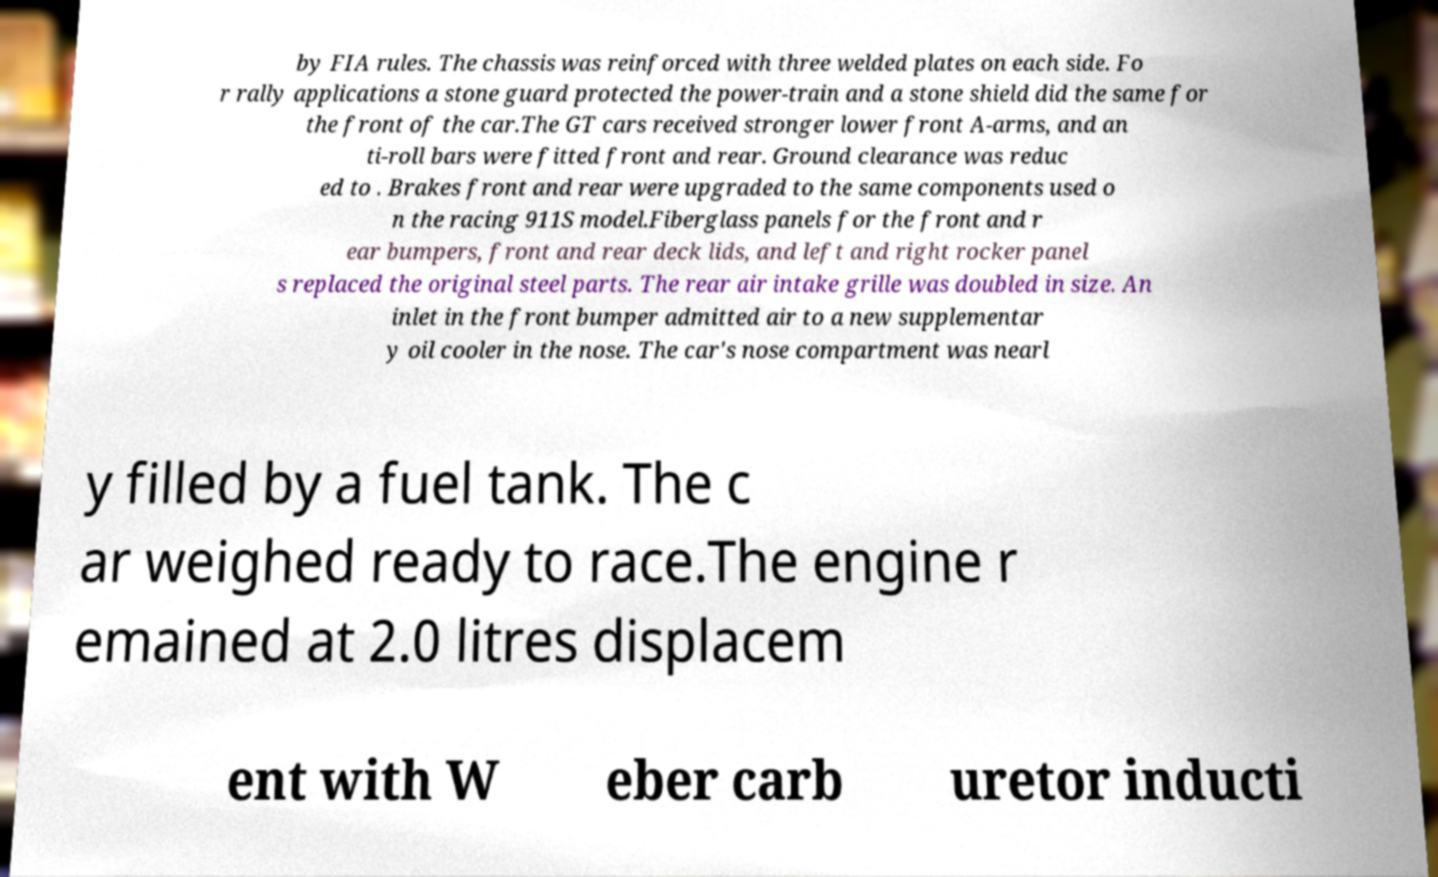Could you extract and type out the text from this image? by FIA rules. The chassis was reinforced with three welded plates on each side. Fo r rally applications a stone guard protected the power-train and a stone shield did the same for the front of the car.The GT cars received stronger lower front A-arms, and an ti-roll bars were fitted front and rear. Ground clearance was reduc ed to . Brakes front and rear were upgraded to the same components used o n the racing 911S model.Fiberglass panels for the front and r ear bumpers, front and rear deck lids, and left and right rocker panel s replaced the original steel parts. The rear air intake grille was doubled in size. An inlet in the front bumper admitted air to a new supplementar y oil cooler in the nose. The car's nose compartment was nearl y filled by a fuel tank. The c ar weighed ready to race.The engine r emained at 2.0 litres displacem ent with W eber carb uretor inducti 